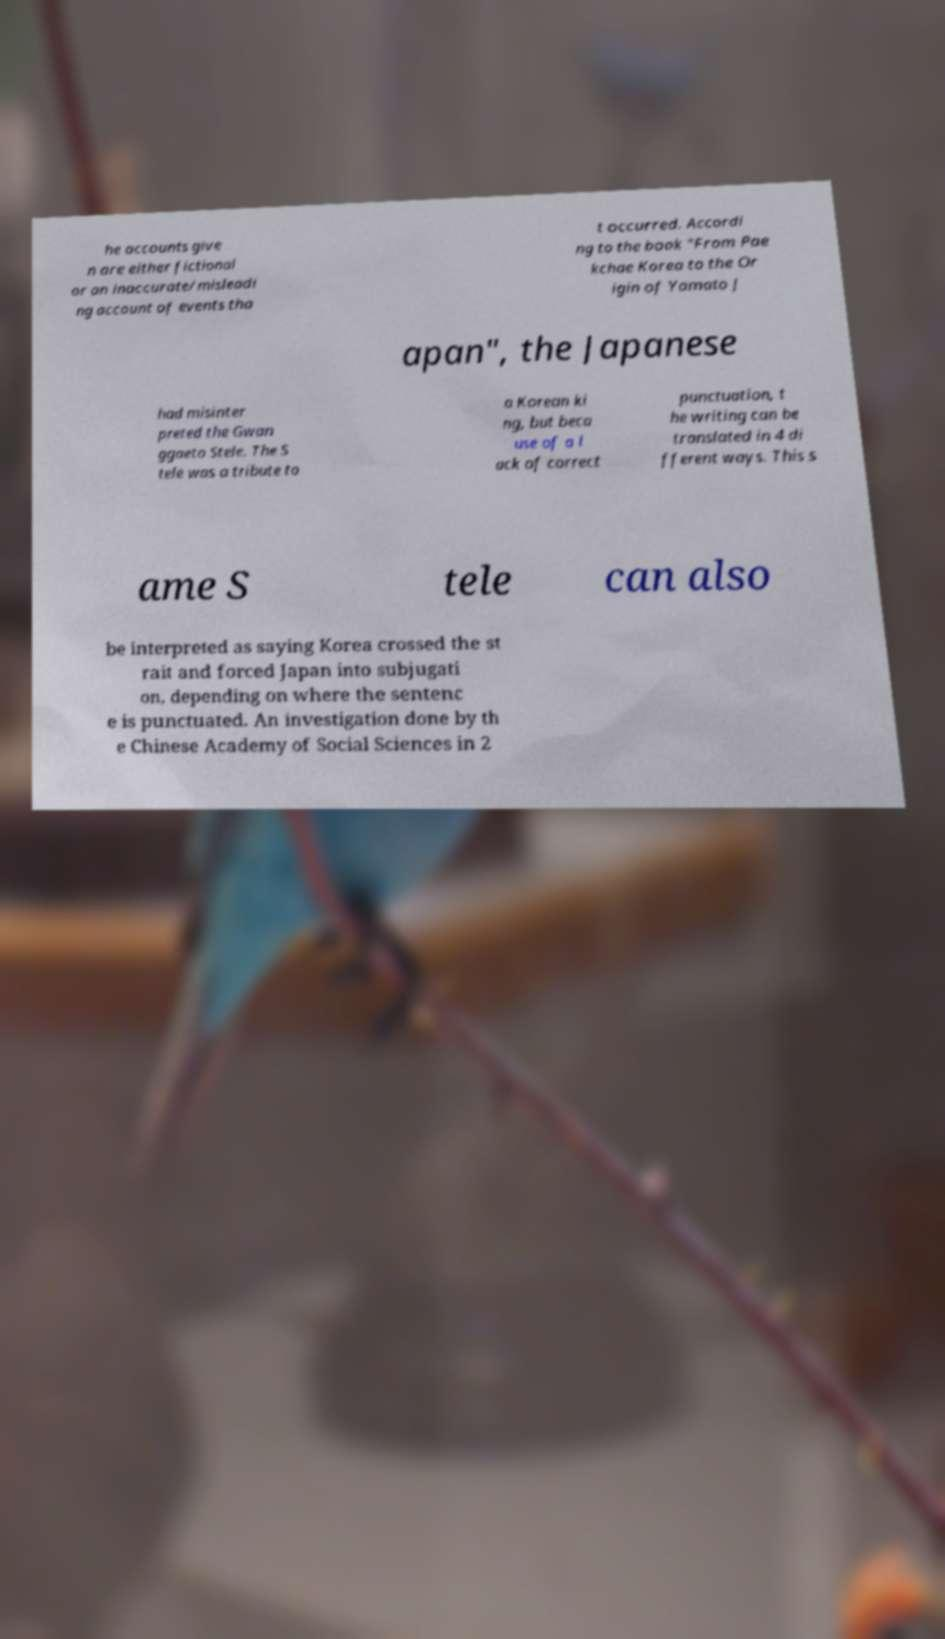There's text embedded in this image that I need extracted. Can you transcribe it verbatim? he accounts give n are either fictional or an inaccurate/misleadi ng account of events tha t occurred. Accordi ng to the book "From Pae kchae Korea to the Or igin of Yamato J apan", the Japanese had misinter preted the Gwan ggaeto Stele. The S tele was a tribute to a Korean ki ng, but beca use of a l ack of correct punctuation, t he writing can be translated in 4 di fferent ways. This s ame S tele can also be interpreted as saying Korea crossed the st rait and forced Japan into subjugati on, depending on where the sentenc e is punctuated. An investigation done by th e Chinese Academy of Social Sciences in 2 